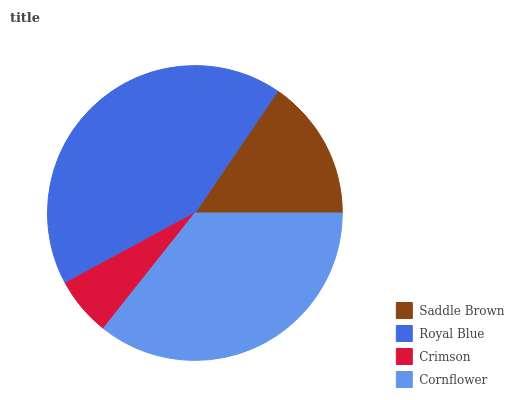Is Crimson the minimum?
Answer yes or no. Yes. Is Royal Blue the maximum?
Answer yes or no. Yes. Is Royal Blue the minimum?
Answer yes or no. No. Is Crimson the maximum?
Answer yes or no. No. Is Royal Blue greater than Crimson?
Answer yes or no. Yes. Is Crimson less than Royal Blue?
Answer yes or no. Yes. Is Crimson greater than Royal Blue?
Answer yes or no. No. Is Royal Blue less than Crimson?
Answer yes or no. No. Is Cornflower the high median?
Answer yes or no. Yes. Is Saddle Brown the low median?
Answer yes or no. Yes. Is Royal Blue the high median?
Answer yes or no. No. Is Crimson the low median?
Answer yes or no. No. 